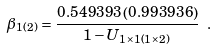Convert formula to latex. <formula><loc_0><loc_0><loc_500><loc_500>\beta _ { 1 ( 2 ) } = \frac { 0 . 5 4 9 3 9 3 \left ( 0 . 9 9 3 9 3 6 \right ) } { 1 - U _ { 1 \times 1 \left ( 1 \times 2 \right ) } } \ .</formula> 